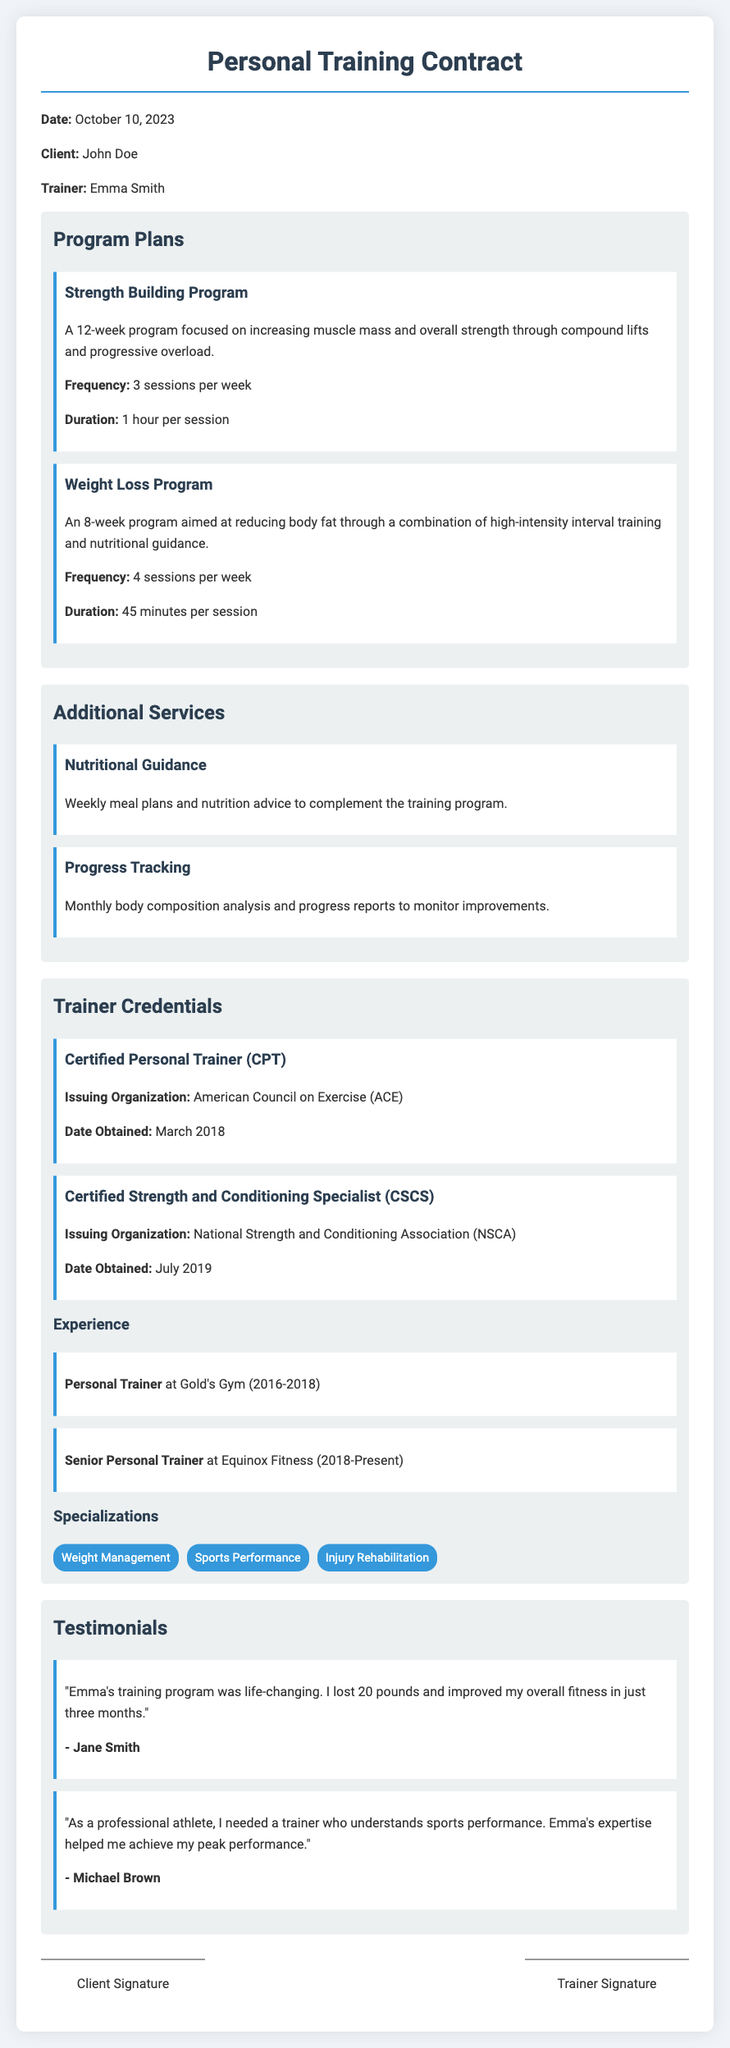What is the date of the contract? The date of the contract is mentioned at the beginning of the document.
Answer: October 10, 2023 Who is the client? The document specifies the name of the client under the client section.
Answer: John Doe What is the frequency of the Weight Loss Program? The frequency is detailed in the program plans section of the document.
Answer: 4 sessions per week How many years of experience does the trainer have at Equinox Fitness? The experience is stated in years from the starting date to the present.
Answer: 5 years What are the specializations of the trainer? The specializations section lists specific areas of expertise.
Answer: Weight Management, Sports Performance, Injury Rehabilitation What is the certification issued by the ACE? The document contains certifications obtained by the trainer, including the certification name.
Answer: Certified Personal Trainer (CPT) How long is the Strength Building Program? The duration of the program is described in the program plans section of the document.
Answer: 12 weeks What kind of guidance is provided alongside the training program? The additional services section indicates what extra support is available to clients.
Answer: Nutritional Guidance What does the first testimonial highlight? The testimonials section contains feedback from clients, summarizing their experiences.
Answer: Life-changing results and weight loss 